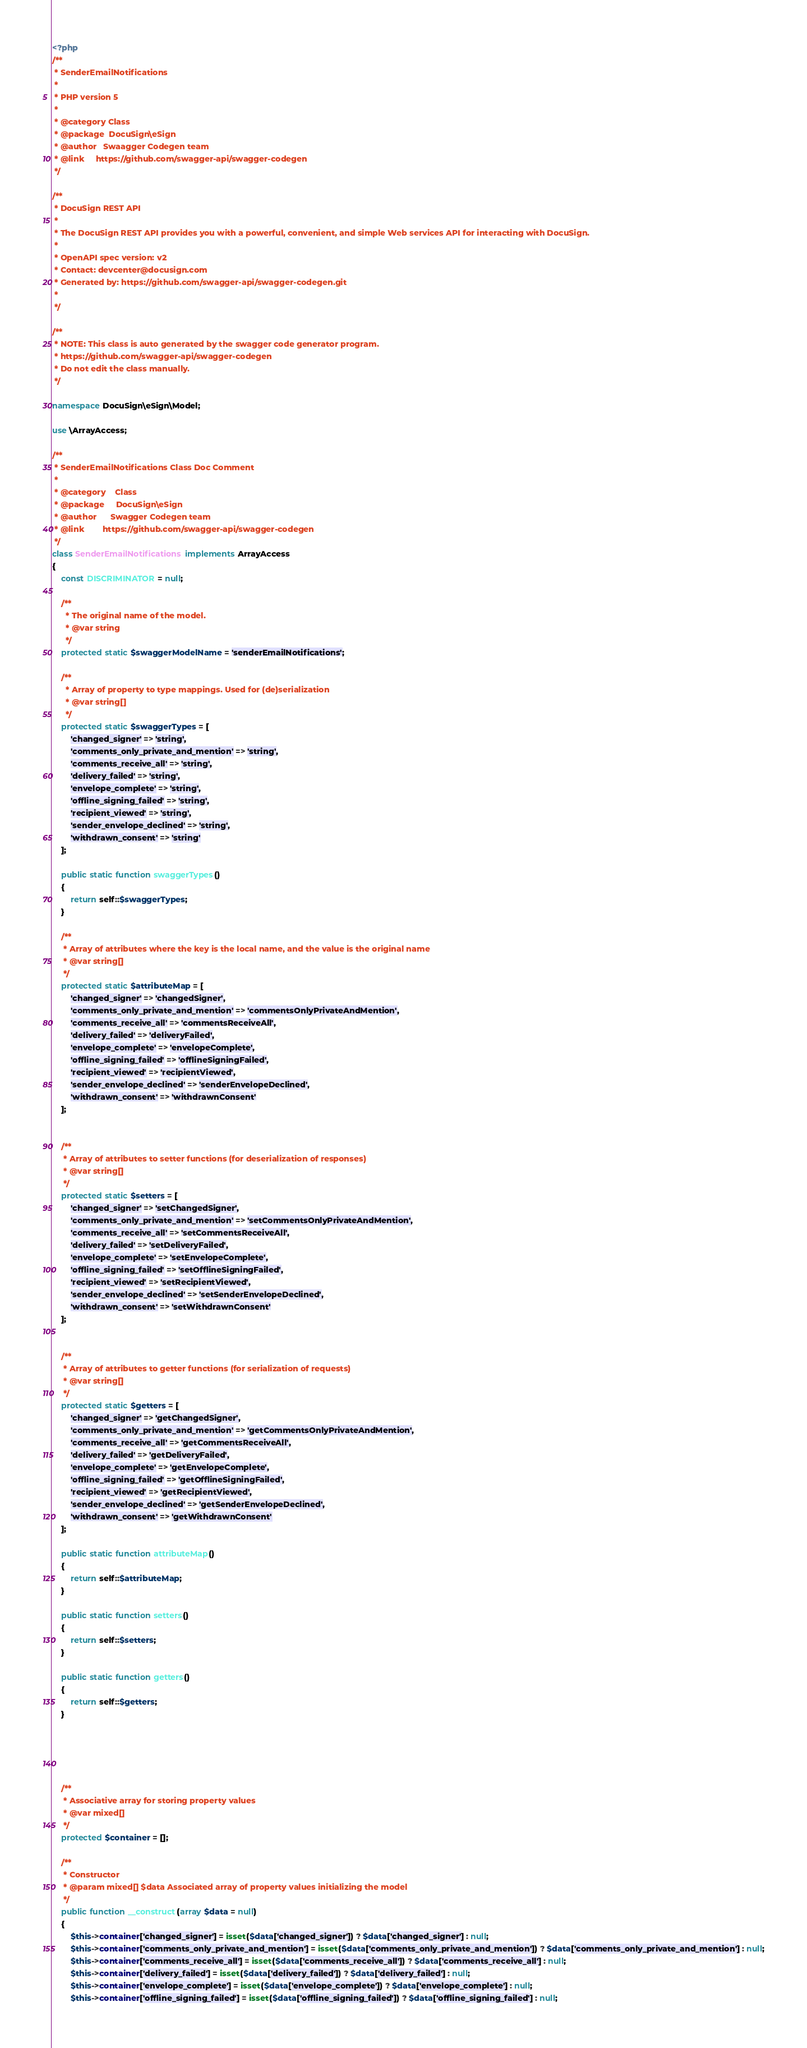Convert code to text. <code><loc_0><loc_0><loc_500><loc_500><_PHP_><?php
/**
 * SenderEmailNotifications
 *
 * PHP version 5
 *
 * @category Class
 * @package  DocuSign\eSign
 * @author   Swaagger Codegen team
 * @link     https://github.com/swagger-api/swagger-codegen
 */

/**
 * DocuSign REST API
 *
 * The DocuSign REST API provides you with a powerful, convenient, and simple Web services API for interacting with DocuSign.
 *
 * OpenAPI spec version: v2
 * Contact: devcenter@docusign.com
 * Generated by: https://github.com/swagger-api/swagger-codegen.git
 *
 */

/**
 * NOTE: This class is auto generated by the swagger code generator program.
 * https://github.com/swagger-api/swagger-codegen
 * Do not edit the class manually.
 */

namespace DocuSign\eSign\Model;

use \ArrayAccess;

/**
 * SenderEmailNotifications Class Doc Comment
 *
 * @category    Class
 * @package     DocuSign\eSign
 * @author      Swagger Codegen team
 * @link        https://github.com/swagger-api/swagger-codegen
 */
class SenderEmailNotifications implements ArrayAccess
{
    const DISCRIMINATOR = null;

    /**
      * The original name of the model.
      * @var string
      */
    protected static $swaggerModelName = 'senderEmailNotifications';

    /**
      * Array of property to type mappings. Used for (de)serialization
      * @var string[]
      */
    protected static $swaggerTypes = [
        'changed_signer' => 'string',
        'comments_only_private_and_mention' => 'string',
        'comments_receive_all' => 'string',
        'delivery_failed' => 'string',
        'envelope_complete' => 'string',
        'offline_signing_failed' => 'string',
        'recipient_viewed' => 'string',
        'sender_envelope_declined' => 'string',
        'withdrawn_consent' => 'string'
    ];

    public static function swaggerTypes()
    {
        return self::$swaggerTypes;
    }

    /**
     * Array of attributes where the key is the local name, and the value is the original name
     * @var string[]
     */
    protected static $attributeMap = [
        'changed_signer' => 'changedSigner',
        'comments_only_private_and_mention' => 'commentsOnlyPrivateAndMention',
        'comments_receive_all' => 'commentsReceiveAll',
        'delivery_failed' => 'deliveryFailed',
        'envelope_complete' => 'envelopeComplete',
        'offline_signing_failed' => 'offlineSigningFailed',
        'recipient_viewed' => 'recipientViewed',
        'sender_envelope_declined' => 'senderEnvelopeDeclined',
        'withdrawn_consent' => 'withdrawnConsent'
    ];


    /**
     * Array of attributes to setter functions (for deserialization of responses)
     * @var string[]
     */
    protected static $setters = [
        'changed_signer' => 'setChangedSigner',
        'comments_only_private_and_mention' => 'setCommentsOnlyPrivateAndMention',
        'comments_receive_all' => 'setCommentsReceiveAll',
        'delivery_failed' => 'setDeliveryFailed',
        'envelope_complete' => 'setEnvelopeComplete',
        'offline_signing_failed' => 'setOfflineSigningFailed',
        'recipient_viewed' => 'setRecipientViewed',
        'sender_envelope_declined' => 'setSenderEnvelopeDeclined',
        'withdrawn_consent' => 'setWithdrawnConsent'
    ];


    /**
     * Array of attributes to getter functions (for serialization of requests)
     * @var string[]
     */
    protected static $getters = [
        'changed_signer' => 'getChangedSigner',
        'comments_only_private_and_mention' => 'getCommentsOnlyPrivateAndMention',
        'comments_receive_all' => 'getCommentsReceiveAll',
        'delivery_failed' => 'getDeliveryFailed',
        'envelope_complete' => 'getEnvelopeComplete',
        'offline_signing_failed' => 'getOfflineSigningFailed',
        'recipient_viewed' => 'getRecipientViewed',
        'sender_envelope_declined' => 'getSenderEnvelopeDeclined',
        'withdrawn_consent' => 'getWithdrawnConsent'
    ];

    public static function attributeMap()
    {
        return self::$attributeMap;
    }

    public static function setters()
    {
        return self::$setters;
    }

    public static function getters()
    {
        return self::$getters;
    }

    

    

    /**
     * Associative array for storing property values
     * @var mixed[]
     */
    protected $container = [];

    /**
     * Constructor
     * @param mixed[] $data Associated array of property values initializing the model
     */
    public function __construct(array $data = null)
    {
        $this->container['changed_signer'] = isset($data['changed_signer']) ? $data['changed_signer'] : null;
        $this->container['comments_only_private_and_mention'] = isset($data['comments_only_private_and_mention']) ? $data['comments_only_private_and_mention'] : null;
        $this->container['comments_receive_all'] = isset($data['comments_receive_all']) ? $data['comments_receive_all'] : null;
        $this->container['delivery_failed'] = isset($data['delivery_failed']) ? $data['delivery_failed'] : null;
        $this->container['envelope_complete'] = isset($data['envelope_complete']) ? $data['envelope_complete'] : null;
        $this->container['offline_signing_failed'] = isset($data['offline_signing_failed']) ? $data['offline_signing_failed'] : null;</code> 